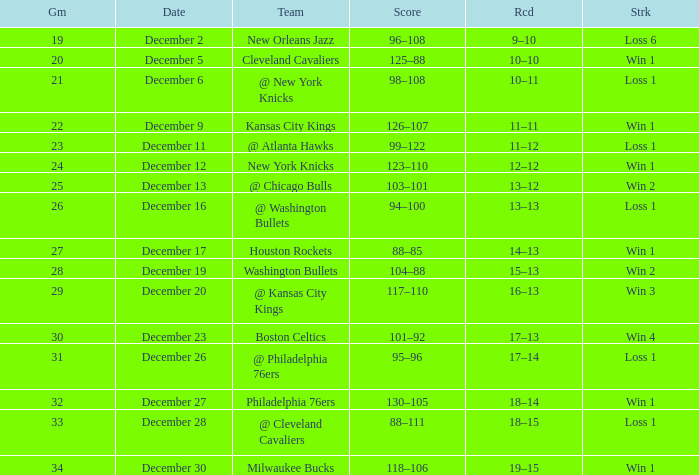What Game had a Score of 101–92? 30.0. 